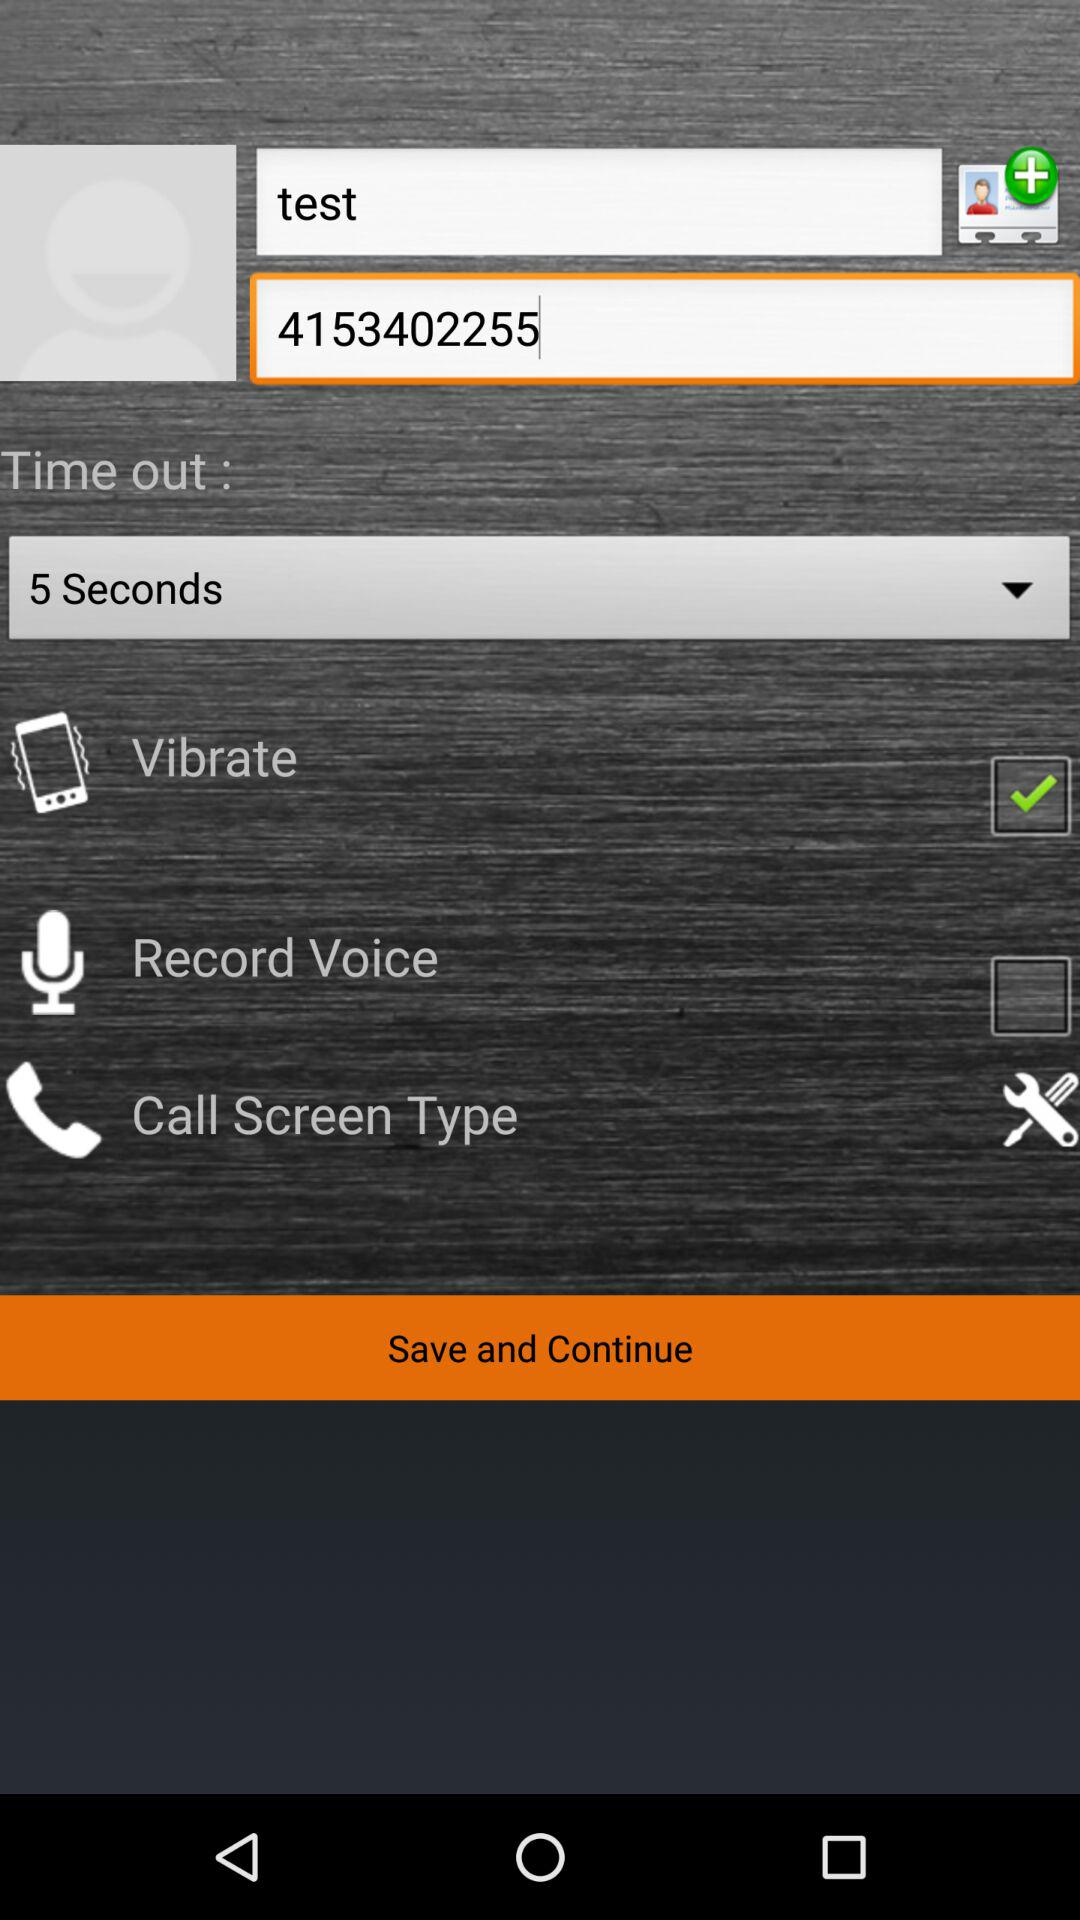What is the status of "Call Screen Type"?
When the provided information is insufficient, respond with <no answer>. <no answer> 